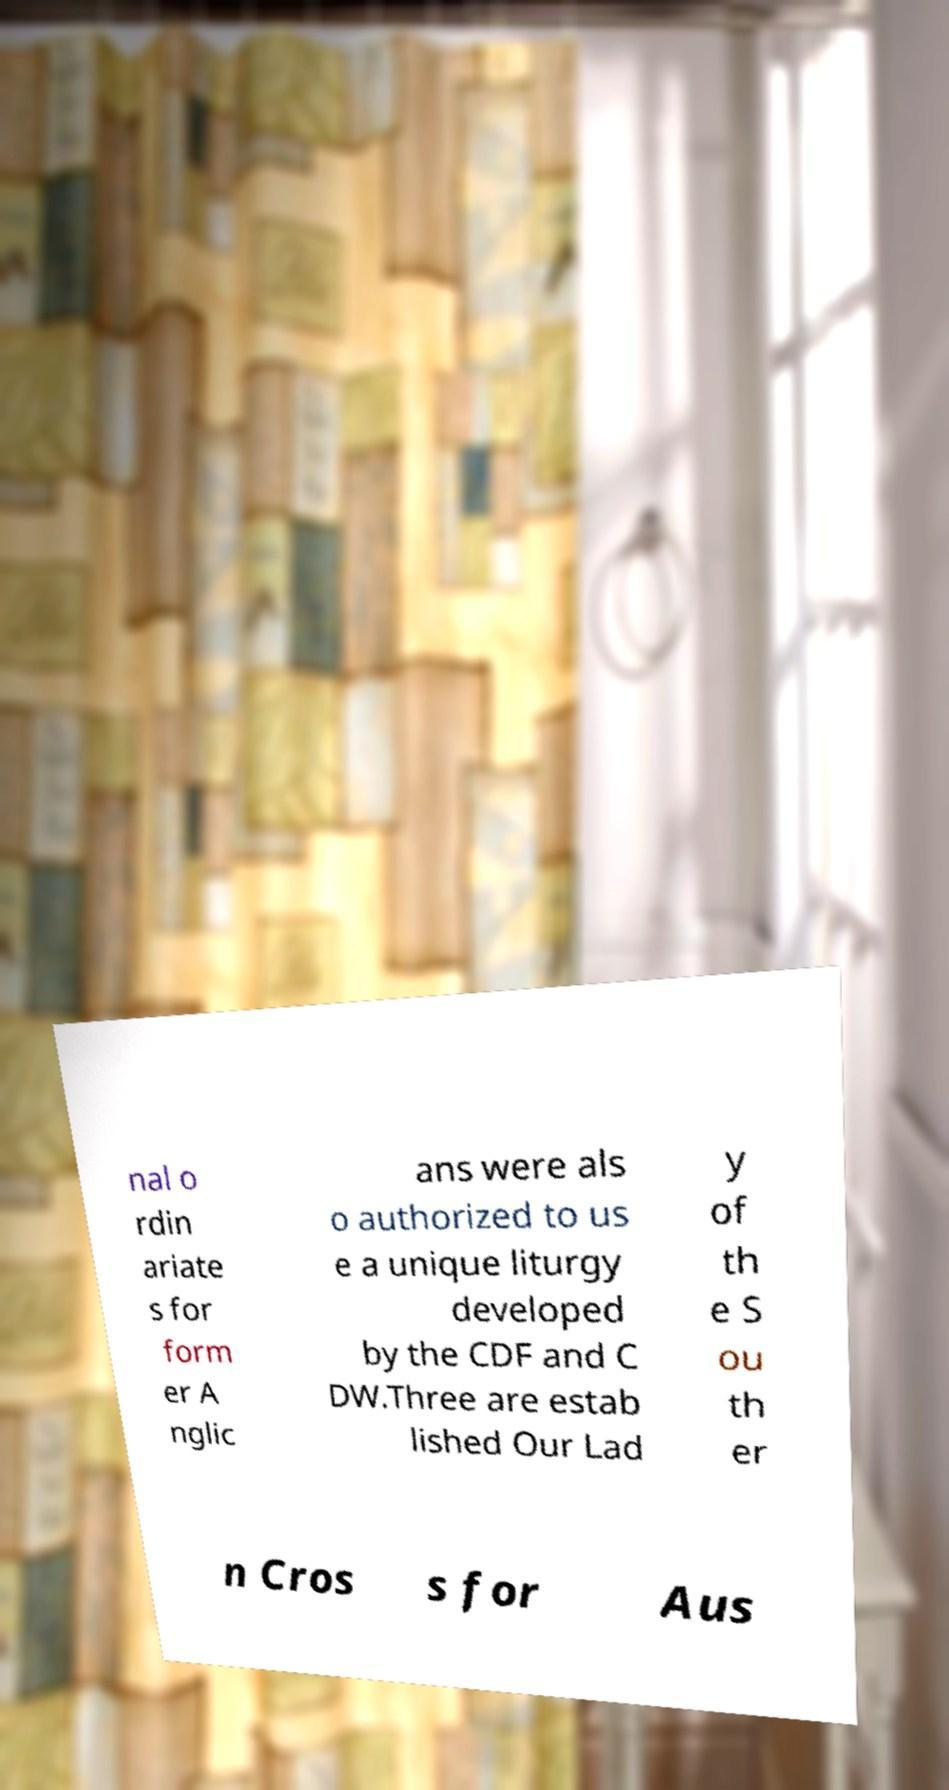Could you extract and type out the text from this image? nal o rdin ariate s for form er A nglic ans were als o authorized to us e a unique liturgy developed by the CDF and C DW.Three are estab lished Our Lad y of th e S ou th er n Cros s for Aus 